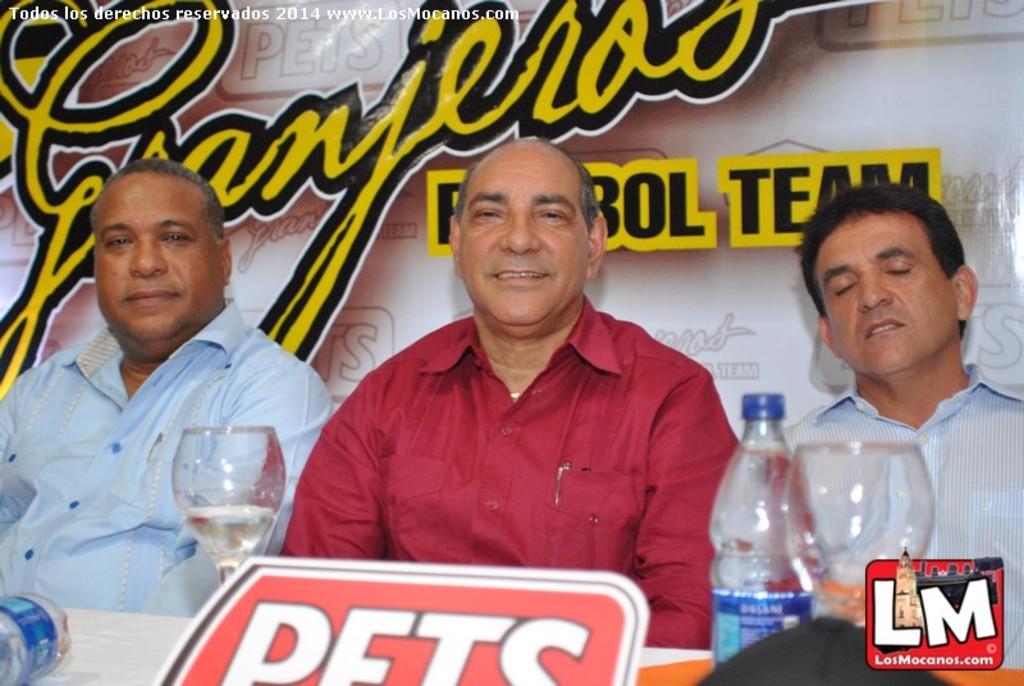What are the first two letters of the last word on the advert behind these men?
Your answer should be very brief. Te. 